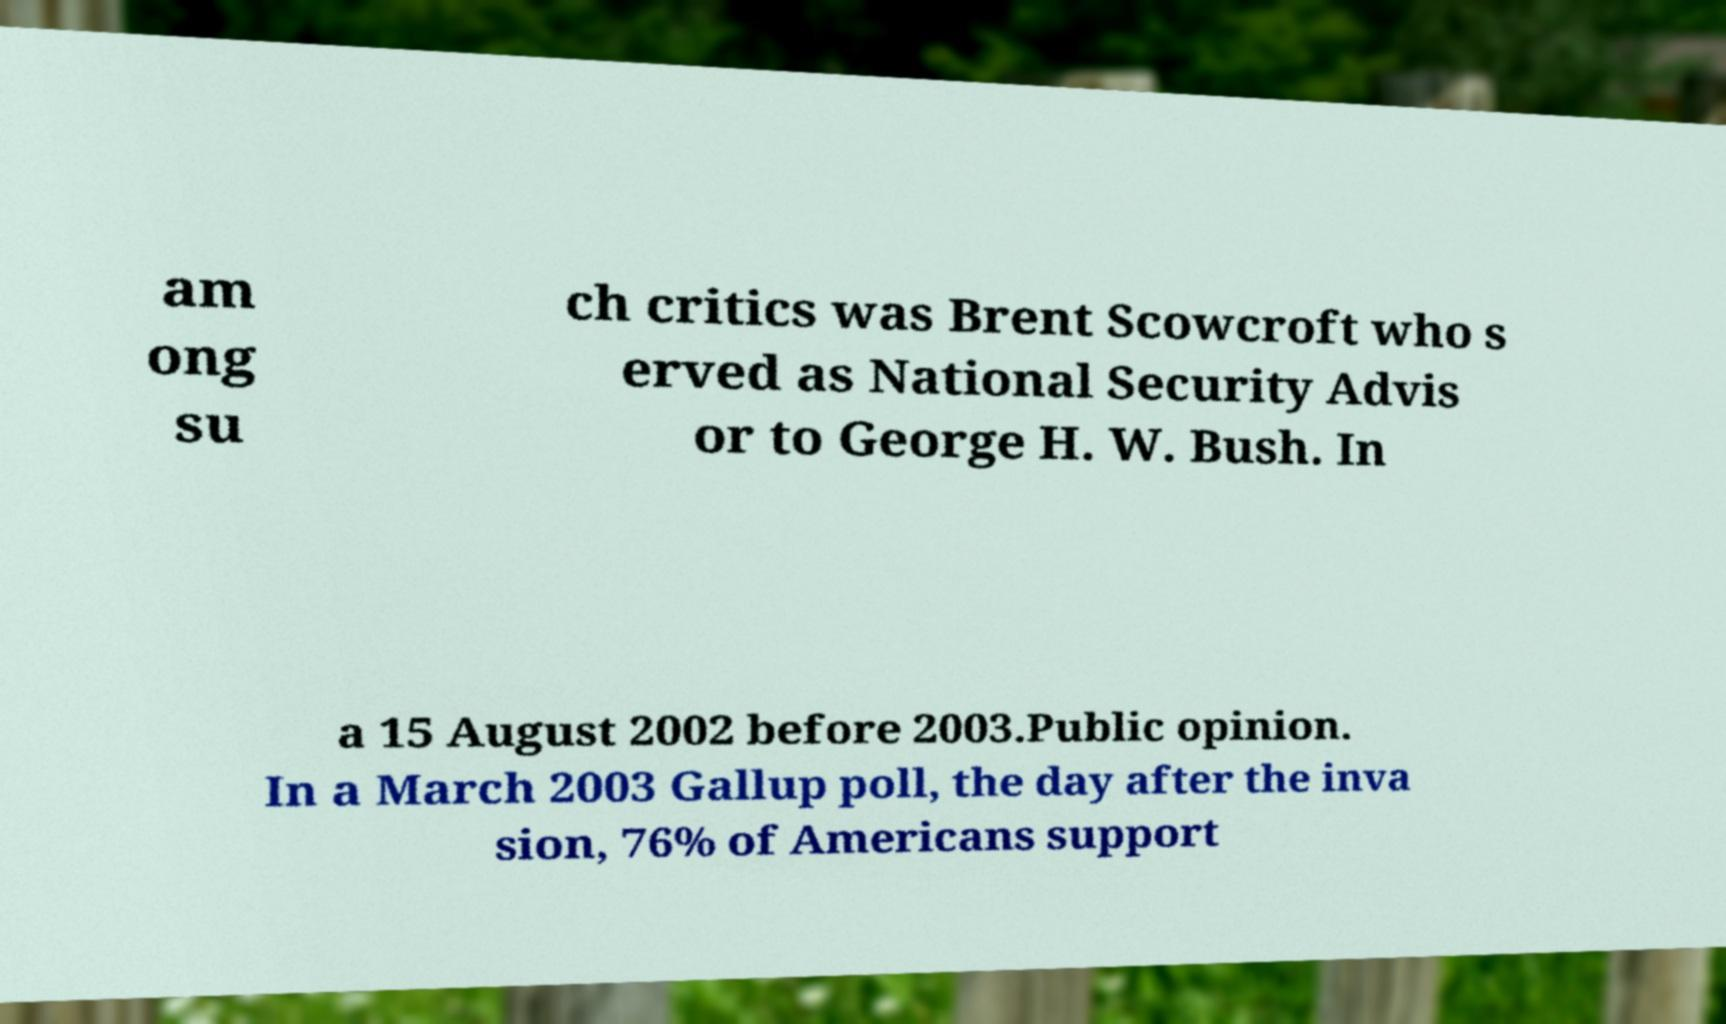Please identify and transcribe the text found in this image. am ong su ch critics was Brent Scowcroft who s erved as National Security Advis or to George H. W. Bush. In a 15 August 2002 before 2003.Public opinion. In a March 2003 Gallup poll, the day after the inva sion, 76% of Americans support 